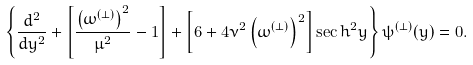<formula> <loc_0><loc_0><loc_500><loc_500>\left \{ \frac { d ^ { 2 } } { d y ^ { 2 } } + \left [ \frac { \left ( \omega ^ { ( \perp ) } \right ) ^ { 2 } } { \mu ^ { 2 } } - 1 \right ] + \left [ 6 + 4 \nu ^ { 2 } \left ( \omega ^ { ( \perp ) } \right ) ^ { 2 } \right ] \sec h ^ { 2 } y \right \} \psi ^ { ( \perp ) } ( y ) = 0 .</formula> 